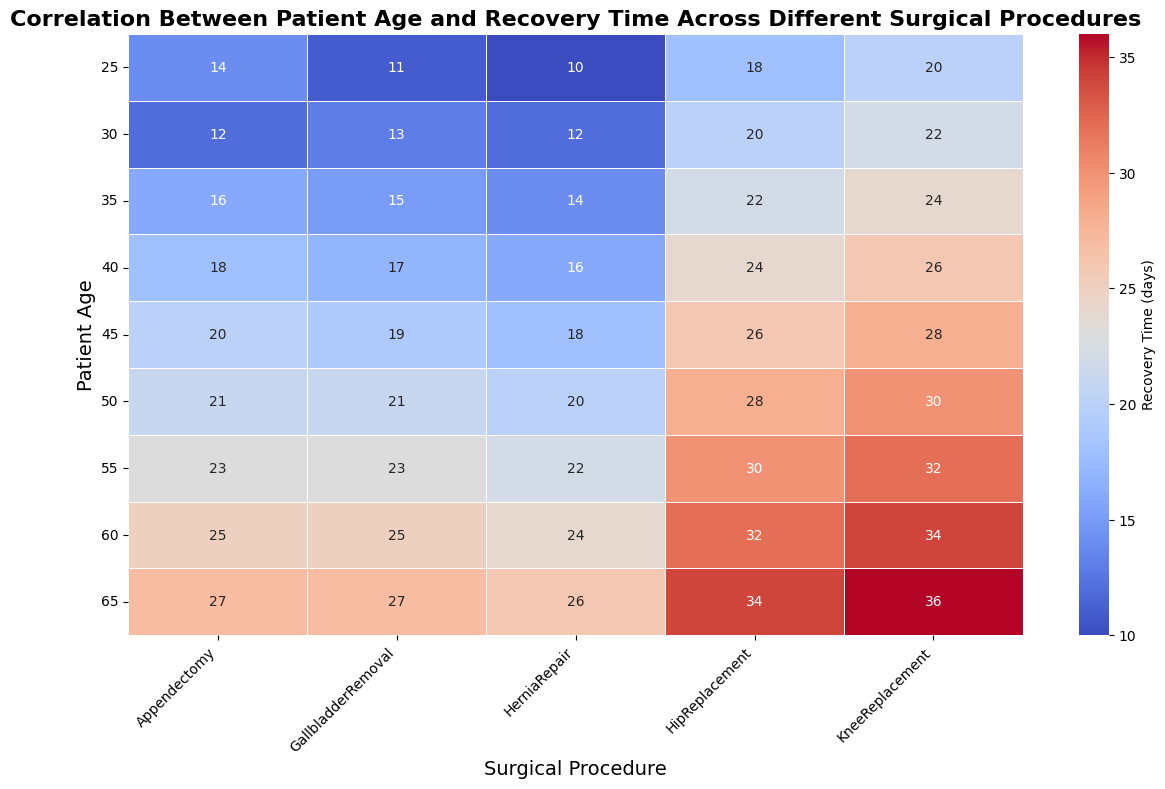Which surgical procedure has the longest recovery time for a 60-year-old patient? Look at the column corresponding to the 60-year age group and find the highest recovery time value. The highest value is 34 days for KneeReplacement.
Answer: KneeReplacement Which age group has the shortest recovery time for GallbladderRemoval? Look at the row corresponding to GallbladderRemoval and find the lowest recovery time value. The lowest value is 11 days for the 25-year age group.
Answer: 25 Compare the recovery times of Appendectomy for patients aged 35 and 50. Which is greater? Look at the Appendectomy column for both 35 and 50-year-old patients. The recovery times are 16 days (35 years) and 21 days (50 years). 21 days is greater than 16 days.
Answer: 50 What is the difference in recovery time for HerniaRepair between patients aged 40 and 55? Look at the HerniaRepair column for 40 and 55-year-old patients. The recovery times are 16 and 22 days respectively. The difference is 22 - 16 = 6 days.
Answer: 6 days Which age group shows the most variation in recovery times across all surgical procedures, and what is the range? Calculate the range of recovery times for each age group by subtracting the smallest value from the largest value within that age group. The age group 60 has the largest variance as it ranges from 24 to 34 days, giving a range of 10 days.
Answer: 60, 10 days What is the average recovery time for a 50-year-old patient across all surgical procedures? Sum the recovery times for the 50-year-old group (21, 20, 21, 28, 30) and divide by the number of procedures (5). The sum is 120 and the average is 120 / 5 = 24 days.
Answer: 24 days Which surgical procedure generally has the lowest recovery times across all age groups? Compare the average recovery times of each surgical procedure across all age groups. By visual inspection, HerniaRepair has generally the lowest recovery times.
Answer: HerniaRepair Are there any surgical procedures where the recovery times increase consistently with age? Check for each surgical procedure to see if recovery times increase with age. Both HipReplacement and KneeReplacement show consistent increases in recovery times as age increases.
Answer: HipReplacement, KneeReplacement 